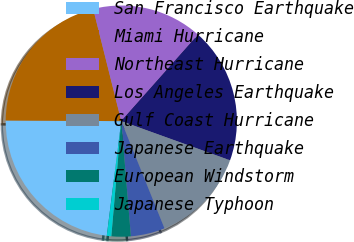<chart> <loc_0><loc_0><loc_500><loc_500><pie_chart><fcel>San Francisco Earthquake<fcel>Miami Hurricane<fcel>Northeast Hurricane<fcel>Los Angeles Earthquake<fcel>Gulf Coast Hurricane<fcel>Japanese Earthquake<fcel>European Windstorm<fcel>Japanese Typhoon<nl><fcel>23.08%<fcel>21.01%<fcel>15.47%<fcel>18.94%<fcel>13.4%<fcel>4.77%<fcel>2.7%<fcel>0.63%<nl></chart> 